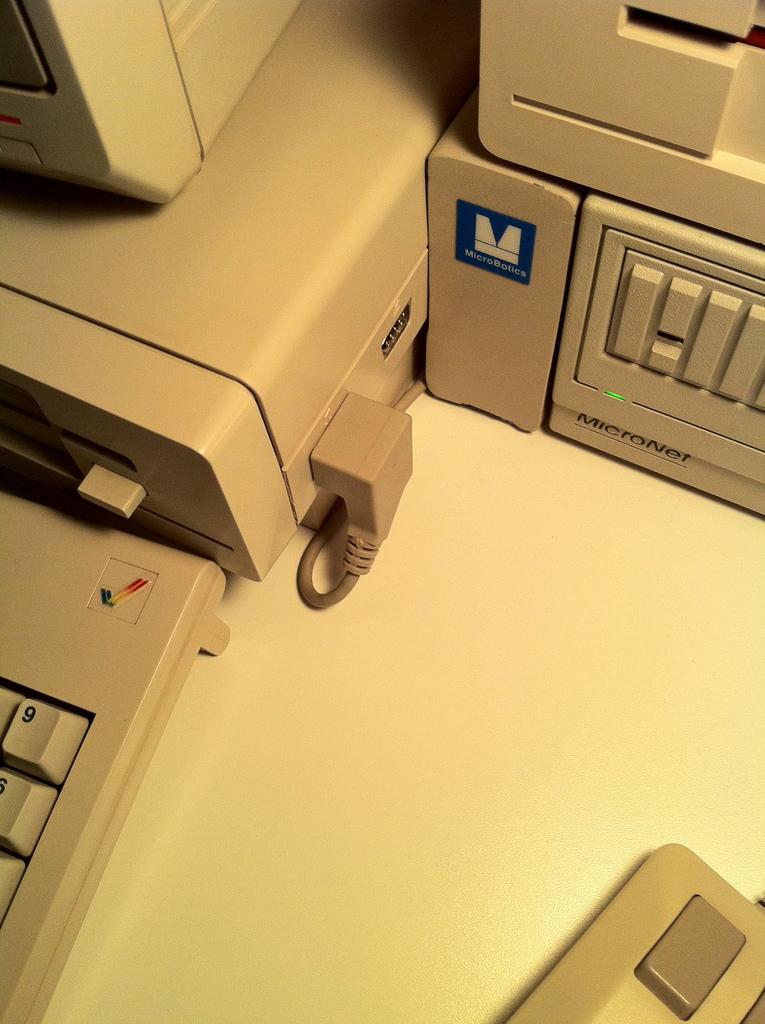What's the number on the keyboard?
Your answer should be compact. 9. What brand of machine is this, stated below the green light?
Offer a very short reply. Micronet. 